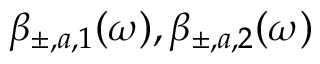Convert formula to latex. <formula><loc_0><loc_0><loc_500><loc_500>\beta _ { \pm , a , 1 } ( \omega ) , \beta _ { \pm , a , 2 } ( \omega )</formula> 